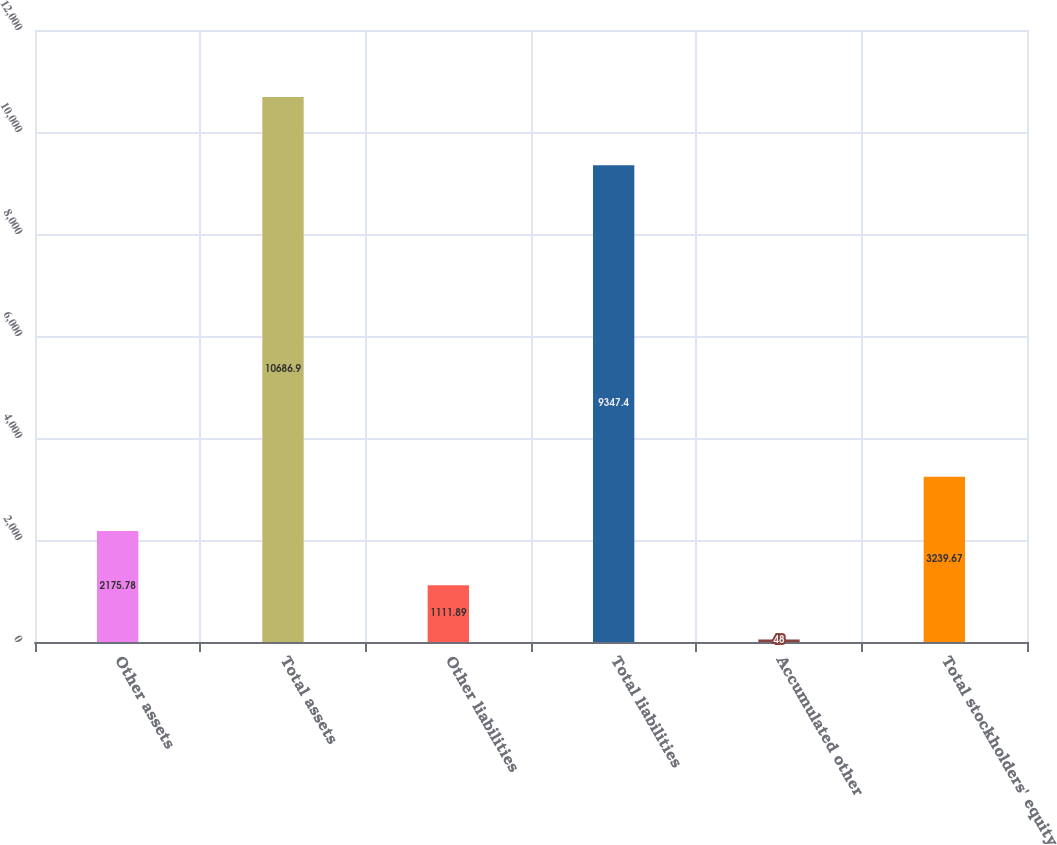<chart> <loc_0><loc_0><loc_500><loc_500><bar_chart><fcel>Other assets<fcel>Total assets<fcel>Other liabilities<fcel>Total liabilities<fcel>Accumulated other<fcel>Total stockholders' equity<nl><fcel>2175.78<fcel>10686.9<fcel>1111.89<fcel>9347.4<fcel>48<fcel>3239.67<nl></chart> 